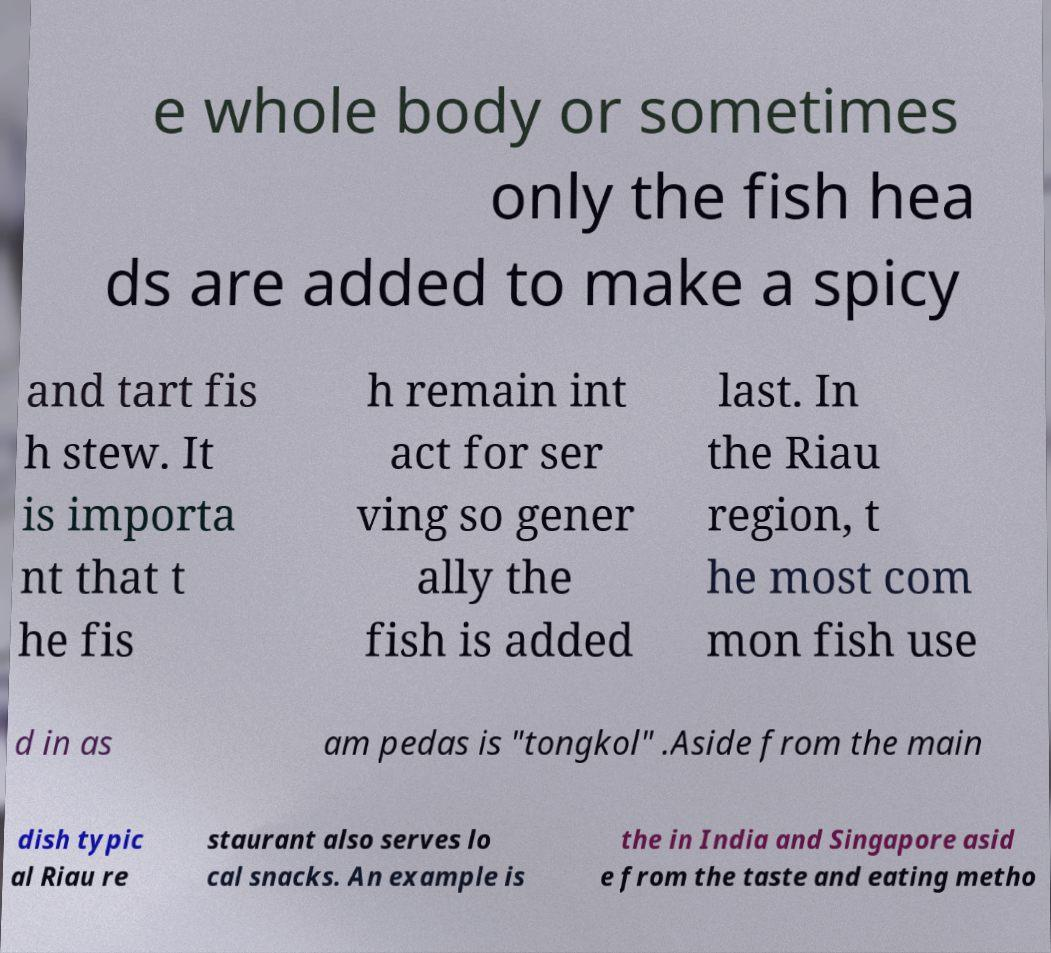Please identify and transcribe the text found in this image. e whole body or sometimes only the fish hea ds are added to make a spicy and tart fis h stew. It is importa nt that t he fis h remain int act for ser ving so gener ally the fish is added last. In the Riau region, t he most com mon fish use d in as am pedas is "tongkol" .Aside from the main dish typic al Riau re staurant also serves lo cal snacks. An example is the in India and Singapore asid e from the taste and eating metho 